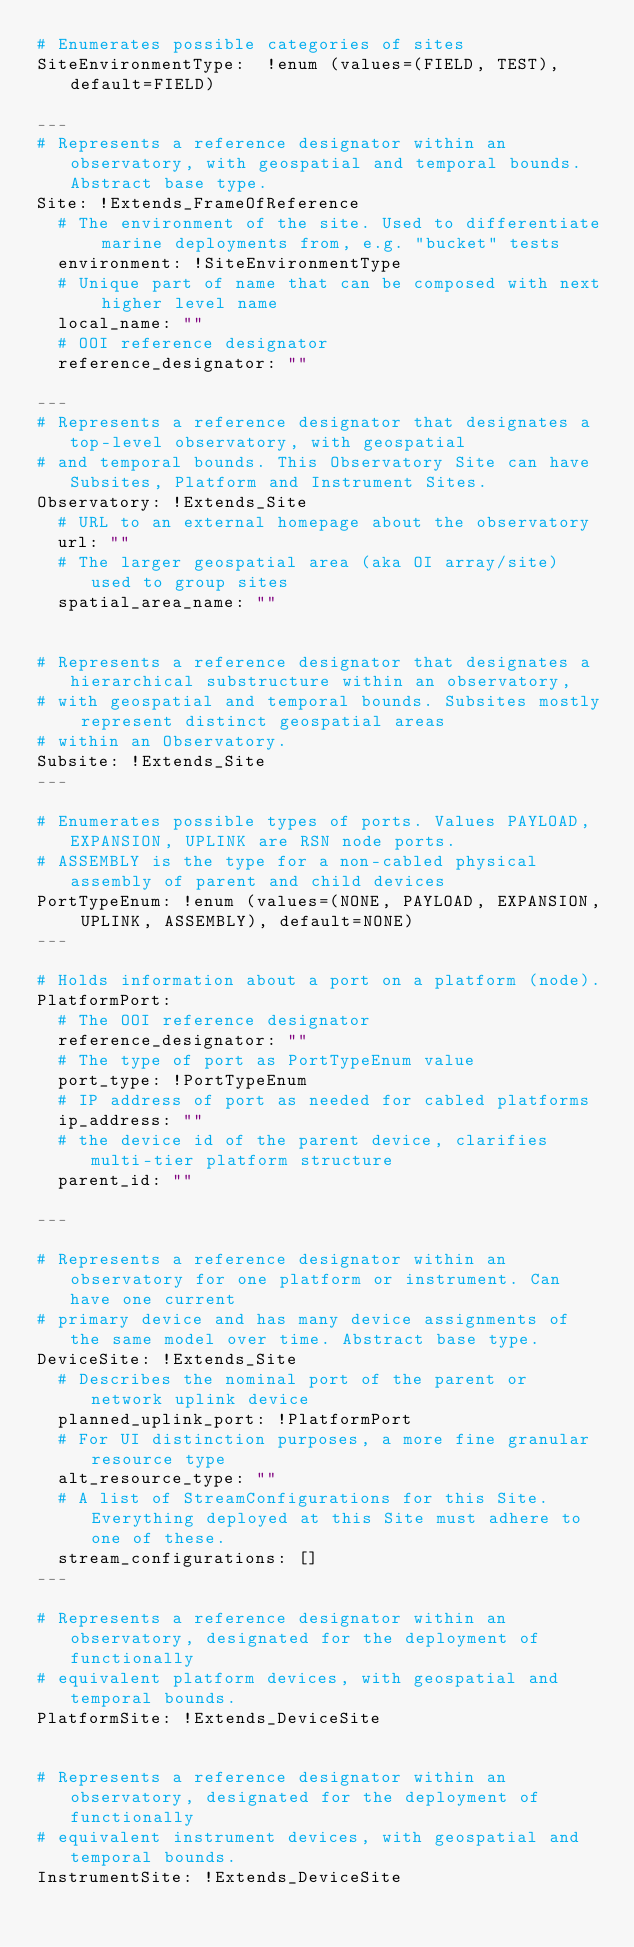Convert code to text. <code><loc_0><loc_0><loc_500><loc_500><_YAML_># Enumerates possible categories of sites
SiteEnvironmentType:  !enum (values=(FIELD, TEST), default=FIELD)

---
# Represents a reference designator within an observatory, with geospatial and temporal bounds. Abstract base type.
Site: !Extends_FrameOfReference
  # The environment of the site. Used to differentiate marine deployments from, e.g. "bucket" tests
  environment: !SiteEnvironmentType
  # Unique part of name that can be composed with next higher level name
  local_name: ""
  # OOI reference designator
  reference_designator: ""

---
# Represents a reference designator that designates a top-level observatory, with geospatial
# and temporal bounds. This Observatory Site can have Subsites, Platform and Instrument Sites.
Observatory: !Extends_Site
  # URL to an external homepage about the observatory
  url: ""
  # The larger geospatial area (aka OI array/site) used to group sites
  spatial_area_name: ""


# Represents a reference designator that designates a hierarchical substructure within an observatory,
# with geospatial and temporal bounds. Subsites mostly represent distinct geospatial areas
# within an Observatory.
Subsite: !Extends_Site
---

# Enumerates possible types of ports. Values PAYLOAD, EXPANSION, UPLINK are RSN node ports.
# ASSEMBLY is the type for a non-cabled physical assembly of parent and child devices
PortTypeEnum: !enum (values=(NONE, PAYLOAD, EXPANSION, UPLINK, ASSEMBLY), default=NONE)
---

# Holds information about a port on a platform (node).
PlatformPort:
  # The OOI reference designator
  reference_designator: ""
  # The type of port as PortTypeEnum value
  port_type: !PortTypeEnum
  # IP address of port as needed for cabled platforms
  ip_address: ""
  # the device id of the parent device, clarifies multi-tier platform structure
  parent_id: ""

---

# Represents a reference designator within an observatory for one platform or instrument. Can have one current
# primary device and has many device assignments of the same model over time. Abstract base type.
DeviceSite: !Extends_Site
  # Describes the nominal port of the parent or network uplink device
  planned_uplink_port: !PlatformPort
  # For UI distinction purposes, a more fine granular resource type
  alt_resource_type: ""
  # A list of StreamConfigurations for this Site. Everything deployed at this Site must adhere to one of these.
  stream_configurations: []
---

# Represents a reference designator within an observatory, designated for the deployment of functionally
# equivalent platform devices, with geospatial and temporal bounds.
PlatformSite: !Extends_DeviceSite


# Represents a reference designator within an observatory, designated for the deployment of functionally
# equivalent instrument devices, with geospatial and temporal bounds.
InstrumentSite: !Extends_DeviceSite
</code> 